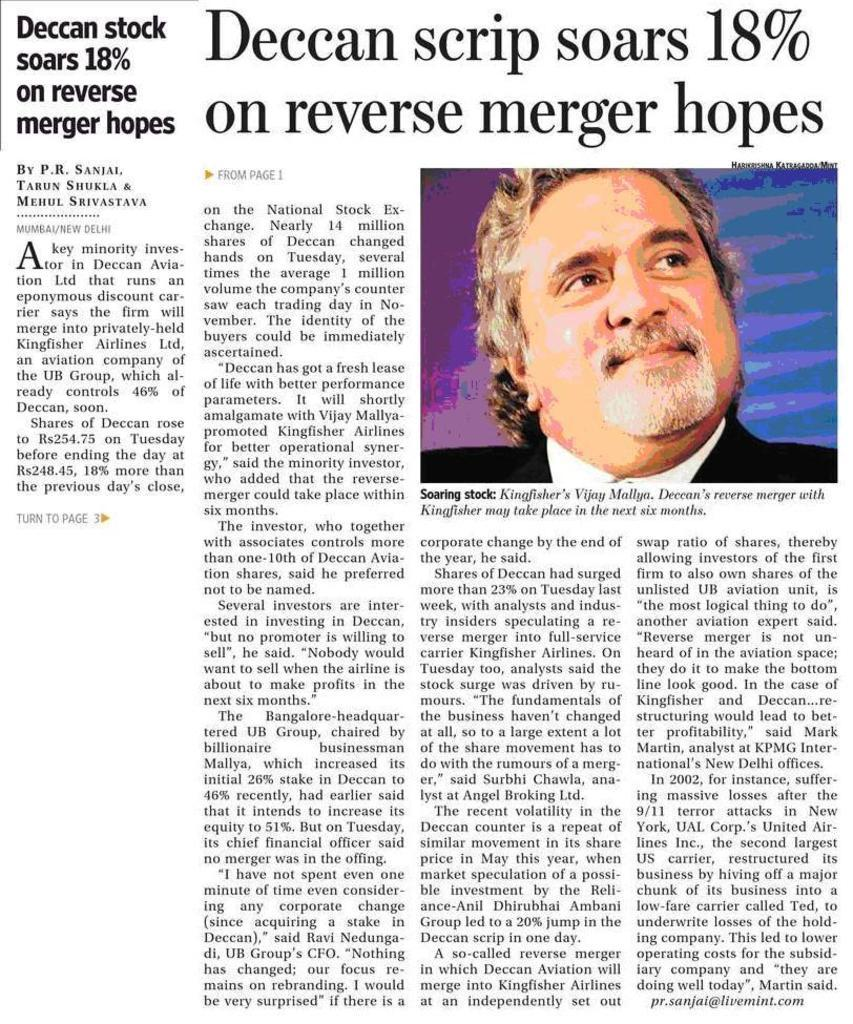What is present in the image that contains information or a message? There is a poster in the image that contains text. What else can be seen on the poster besides the text? The poster has an image of a person. Is there a bath visible in the image? No, there is no bath present in the image. Who is the expert featured on the poster? There is no expert mentioned or depicted on the poster; it only contains text and an image of a person. 